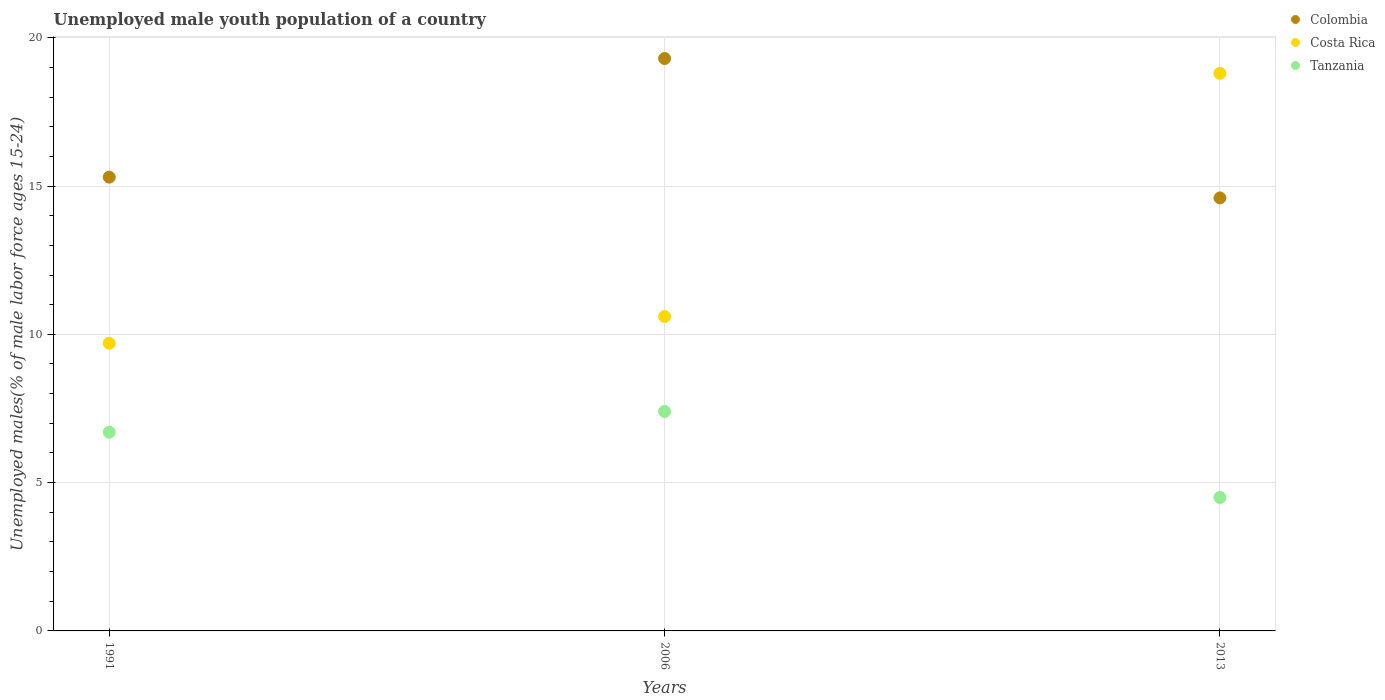How many different coloured dotlines are there?
Your answer should be very brief. 3. Is the number of dotlines equal to the number of legend labels?
Make the answer very short. Yes. What is the percentage of unemployed male youth population in Colombia in 2013?
Your response must be concise. 14.6. Across all years, what is the maximum percentage of unemployed male youth population in Colombia?
Provide a short and direct response. 19.3. What is the total percentage of unemployed male youth population in Tanzania in the graph?
Provide a short and direct response. 18.6. What is the difference between the percentage of unemployed male youth population in Tanzania in 2006 and that in 2013?
Provide a short and direct response. 2.9. What is the difference between the percentage of unemployed male youth population in Colombia in 2006 and the percentage of unemployed male youth population in Tanzania in 2013?
Your answer should be compact. 14.8. What is the average percentage of unemployed male youth population in Tanzania per year?
Offer a terse response. 6.2. In the year 1991, what is the difference between the percentage of unemployed male youth population in Colombia and percentage of unemployed male youth population in Costa Rica?
Offer a very short reply. 5.6. In how many years, is the percentage of unemployed male youth population in Colombia greater than 13 %?
Make the answer very short. 3. What is the ratio of the percentage of unemployed male youth population in Colombia in 2006 to that in 2013?
Give a very brief answer. 1.32. Is the difference between the percentage of unemployed male youth population in Colombia in 1991 and 2006 greater than the difference between the percentage of unemployed male youth population in Costa Rica in 1991 and 2006?
Keep it short and to the point. No. What is the difference between the highest and the second highest percentage of unemployed male youth population in Tanzania?
Provide a succinct answer. 0.7. What is the difference between the highest and the lowest percentage of unemployed male youth population in Costa Rica?
Your answer should be very brief. 9.1. Is it the case that in every year, the sum of the percentage of unemployed male youth population in Costa Rica and percentage of unemployed male youth population in Tanzania  is greater than the percentage of unemployed male youth population in Colombia?
Make the answer very short. No. Is the percentage of unemployed male youth population in Tanzania strictly greater than the percentage of unemployed male youth population in Colombia over the years?
Provide a short and direct response. No. Is the percentage of unemployed male youth population in Colombia strictly less than the percentage of unemployed male youth population in Costa Rica over the years?
Give a very brief answer. No. How many years are there in the graph?
Ensure brevity in your answer.  3. What is the difference between two consecutive major ticks on the Y-axis?
Provide a succinct answer. 5. Are the values on the major ticks of Y-axis written in scientific E-notation?
Offer a terse response. No. Does the graph contain any zero values?
Your response must be concise. No. How many legend labels are there?
Offer a very short reply. 3. How are the legend labels stacked?
Offer a very short reply. Vertical. What is the title of the graph?
Give a very brief answer. Unemployed male youth population of a country. Does "China" appear as one of the legend labels in the graph?
Offer a terse response. No. What is the label or title of the X-axis?
Provide a succinct answer. Years. What is the label or title of the Y-axis?
Provide a short and direct response. Unemployed males(% of male labor force ages 15-24). What is the Unemployed males(% of male labor force ages 15-24) of Colombia in 1991?
Keep it short and to the point. 15.3. What is the Unemployed males(% of male labor force ages 15-24) of Costa Rica in 1991?
Make the answer very short. 9.7. What is the Unemployed males(% of male labor force ages 15-24) of Tanzania in 1991?
Offer a very short reply. 6.7. What is the Unemployed males(% of male labor force ages 15-24) in Colombia in 2006?
Offer a very short reply. 19.3. What is the Unemployed males(% of male labor force ages 15-24) in Costa Rica in 2006?
Your answer should be very brief. 10.6. What is the Unemployed males(% of male labor force ages 15-24) of Tanzania in 2006?
Your answer should be compact. 7.4. What is the Unemployed males(% of male labor force ages 15-24) of Colombia in 2013?
Your answer should be compact. 14.6. What is the Unemployed males(% of male labor force ages 15-24) of Costa Rica in 2013?
Give a very brief answer. 18.8. What is the Unemployed males(% of male labor force ages 15-24) of Tanzania in 2013?
Provide a succinct answer. 4.5. Across all years, what is the maximum Unemployed males(% of male labor force ages 15-24) in Colombia?
Ensure brevity in your answer.  19.3. Across all years, what is the maximum Unemployed males(% of male labor force ages 15-24) of Costa Rica?
Ensure brevity in your answer.  18.8. Across all years, what is the maximum Unemployed males(% of male labor force ages 15-24) of Tanzania?
Ensure brevity in your answer.  7.4. Across all years, what is the minimum Unemployed males(% of male labor force ages 15-24) in Colombia?
Your answer should be very brief. 14.6. Across all years, what is the minimum Unemployed males(% of male labor force ages 15-24) of Costa Rica?
Ensure brevity in your answer.  9.7. Across all years, what is the minimum Unemployed males(% of male labor force ages 15-24) of Tanzania?
Your answer should be very brief. 4.5. What is the total Unemployed males(% of male labor force ages 15-24) in Colombia in the graph?
Your answer should be compact. 49.2. What is the total Unemployed males(% of male labor force ages 15-24) in Costa Rica in the graph?
Offer a terse response. 39.1. What is the difference between the Unemployed males(% of male labor force ages 15-24) in Costa Rica in 1991 and that in 2006?
Your response must be concise. -0.9. What is the difference between the Unemployed males(% of male labor force ages 15-24) in Tanzania in 1991 and that in 2006?
Provide a short and direct response. -0.7. What is the difference between the Unemployed males(% of male labor force ages 15-24) of Costa Rica in 1991 and that in 2013?
Give a very brief answer. -9.1. What is the difference between the Unemployed males(% of male labor force ages 15-24) in Tanzania in 1991 and that in 2013?
Offer a terse response. 2.2. What is the difference between the Unemployed males(% of male labor force ages 15-24) in Tanzania in 2006 and that in 2013?
Your response must be concise. 2.9. What is the difference between the Unemployed males(% of male labor force ages 15-24) in Colombia in 1991 and the Unemployed males(% of male labor force ages 15-24) in Tanzania in 2006?
Your answer should be very brief. 7.9. What is the difference between the Unemployed males(% of male labor force ages 15-24) of Colombia in 1991 and the Unemployed males(% of male labor force ages 15-24) of Costa Rica in 2013?
Your response must be concise. -3.5. What is the difference between the Unemployed males(% of male labor force ages 15-24) in Colombia in 1991 and the Unemployed males(% of male labor force ages 15-24) in Tanzania in 2013?
Offer a terse response. 10.8. What is the difference between the Unemployed males(% of male labor force ages 15-24) in Costa Rica in 1991 and the Unemployed males(% of male labor force ages 15-24) in Tanzania in 2013?
Offer a terse response. 5.2. What is the average Unemployed males(% of male labor force ages 15-24) in Costa Rica per year?
Keep it short and to the point. 13.03. What is the average Unemployed males(% of male labor force ages 15-24) of Tanzania per year?
Give a very brief answer. 6.2. In the year 1991, what is the difference between the Unemployed males(% of male labor force ages 15-24) in Colombia and Unemployed males(% of male labor force ages 15-24) in Costa Rica?
Offer a very short reply. 5.6. In the year 1991, what is the difference between the Unemployed males(% of male labor force ages 15-24) of Colombia and Unemployed males(% of male labor force ages 15-24) of Tanzania?
Your answer should be very brief. 8.6. In the year 2013, what is the difference between the Unemployed males(% of male labor force ages 15-24) in Costa Rica and Unemployed males(% of male labor force ages 15-24) in Tanzania?
Ensure brevity in your answer.  14.3. What is the ratio of the Unemployed males(% of male labor force ages 15-24) of Colombia in 1991 to that in 2006?
Your response must be concise. 0.79. What is the ratio of the Unemployed males(% of male labor force ages 15-24) of Costa Rica in 1991 to that in 2006?
Provide a succinct answer. 0.92. What is the ratio of the Unemployed males(% of male labor force ages 15-24) in Tanzania in 1991 to that in 2006?
Your answer should be very brief. 0.91. What is the ratio of the Unemployed males(% of male labor force ages 15-24) of Colombia in 1991 to that in 2013?
Provide a short and direct response. 1.05. What is the ratio of the Unemployed males(% of male labor force ages 15-24) in Costa Rica in 1991 to that in 2013?
Offer a very short reply. 0.52. What is the ratio of the Unemployed males(% of male labor force ages 15-24) in Tanzania in 1991 to that in 2013?
Your answer should be very brief. 1.49. What is the ratio of the Unemployed males(% of male labor force ages 15-24) of Colombia in 2006 to that in 2013?
Ensure brevity in your answer.  1.32. What is the ratio of the Unemployed males(% of male labor force ages 15-24) of Costa Rica in 2006 to that in 2013?
Keep it short and to the point. 0.56. What is the ratio of the Unemployed males(% of male labor force ages 15-24) of Tanzania in 2006 to that in 2013?
Provide a short and direct response. 1.64. What is the difference between the highest and the second highest Unemployed males(% of male labor force ages 15-24) in Colombia?
Offer a very short reply. 4. What is the difference between the highest and the second highest Unemployed males(% of male labor force ages 15-24) of Tanzania?
Provide a short and direct response. 0.7. What is the difference between the highest and the lowest Unemployed males(% of male labor force ages 15-24) in Colombia?
Offer a very short reply. 4.7. What is the difference between the highest and the lowest Unemployed males(% of male labor force ages 15-24) of Costa Rica?
Your response must be concise. 9.1. What is the difference between the highest and the lowest Unemployed males(% of male labor force ages 15-24) of Tanzania?
Make the answer very short. 2.9. 